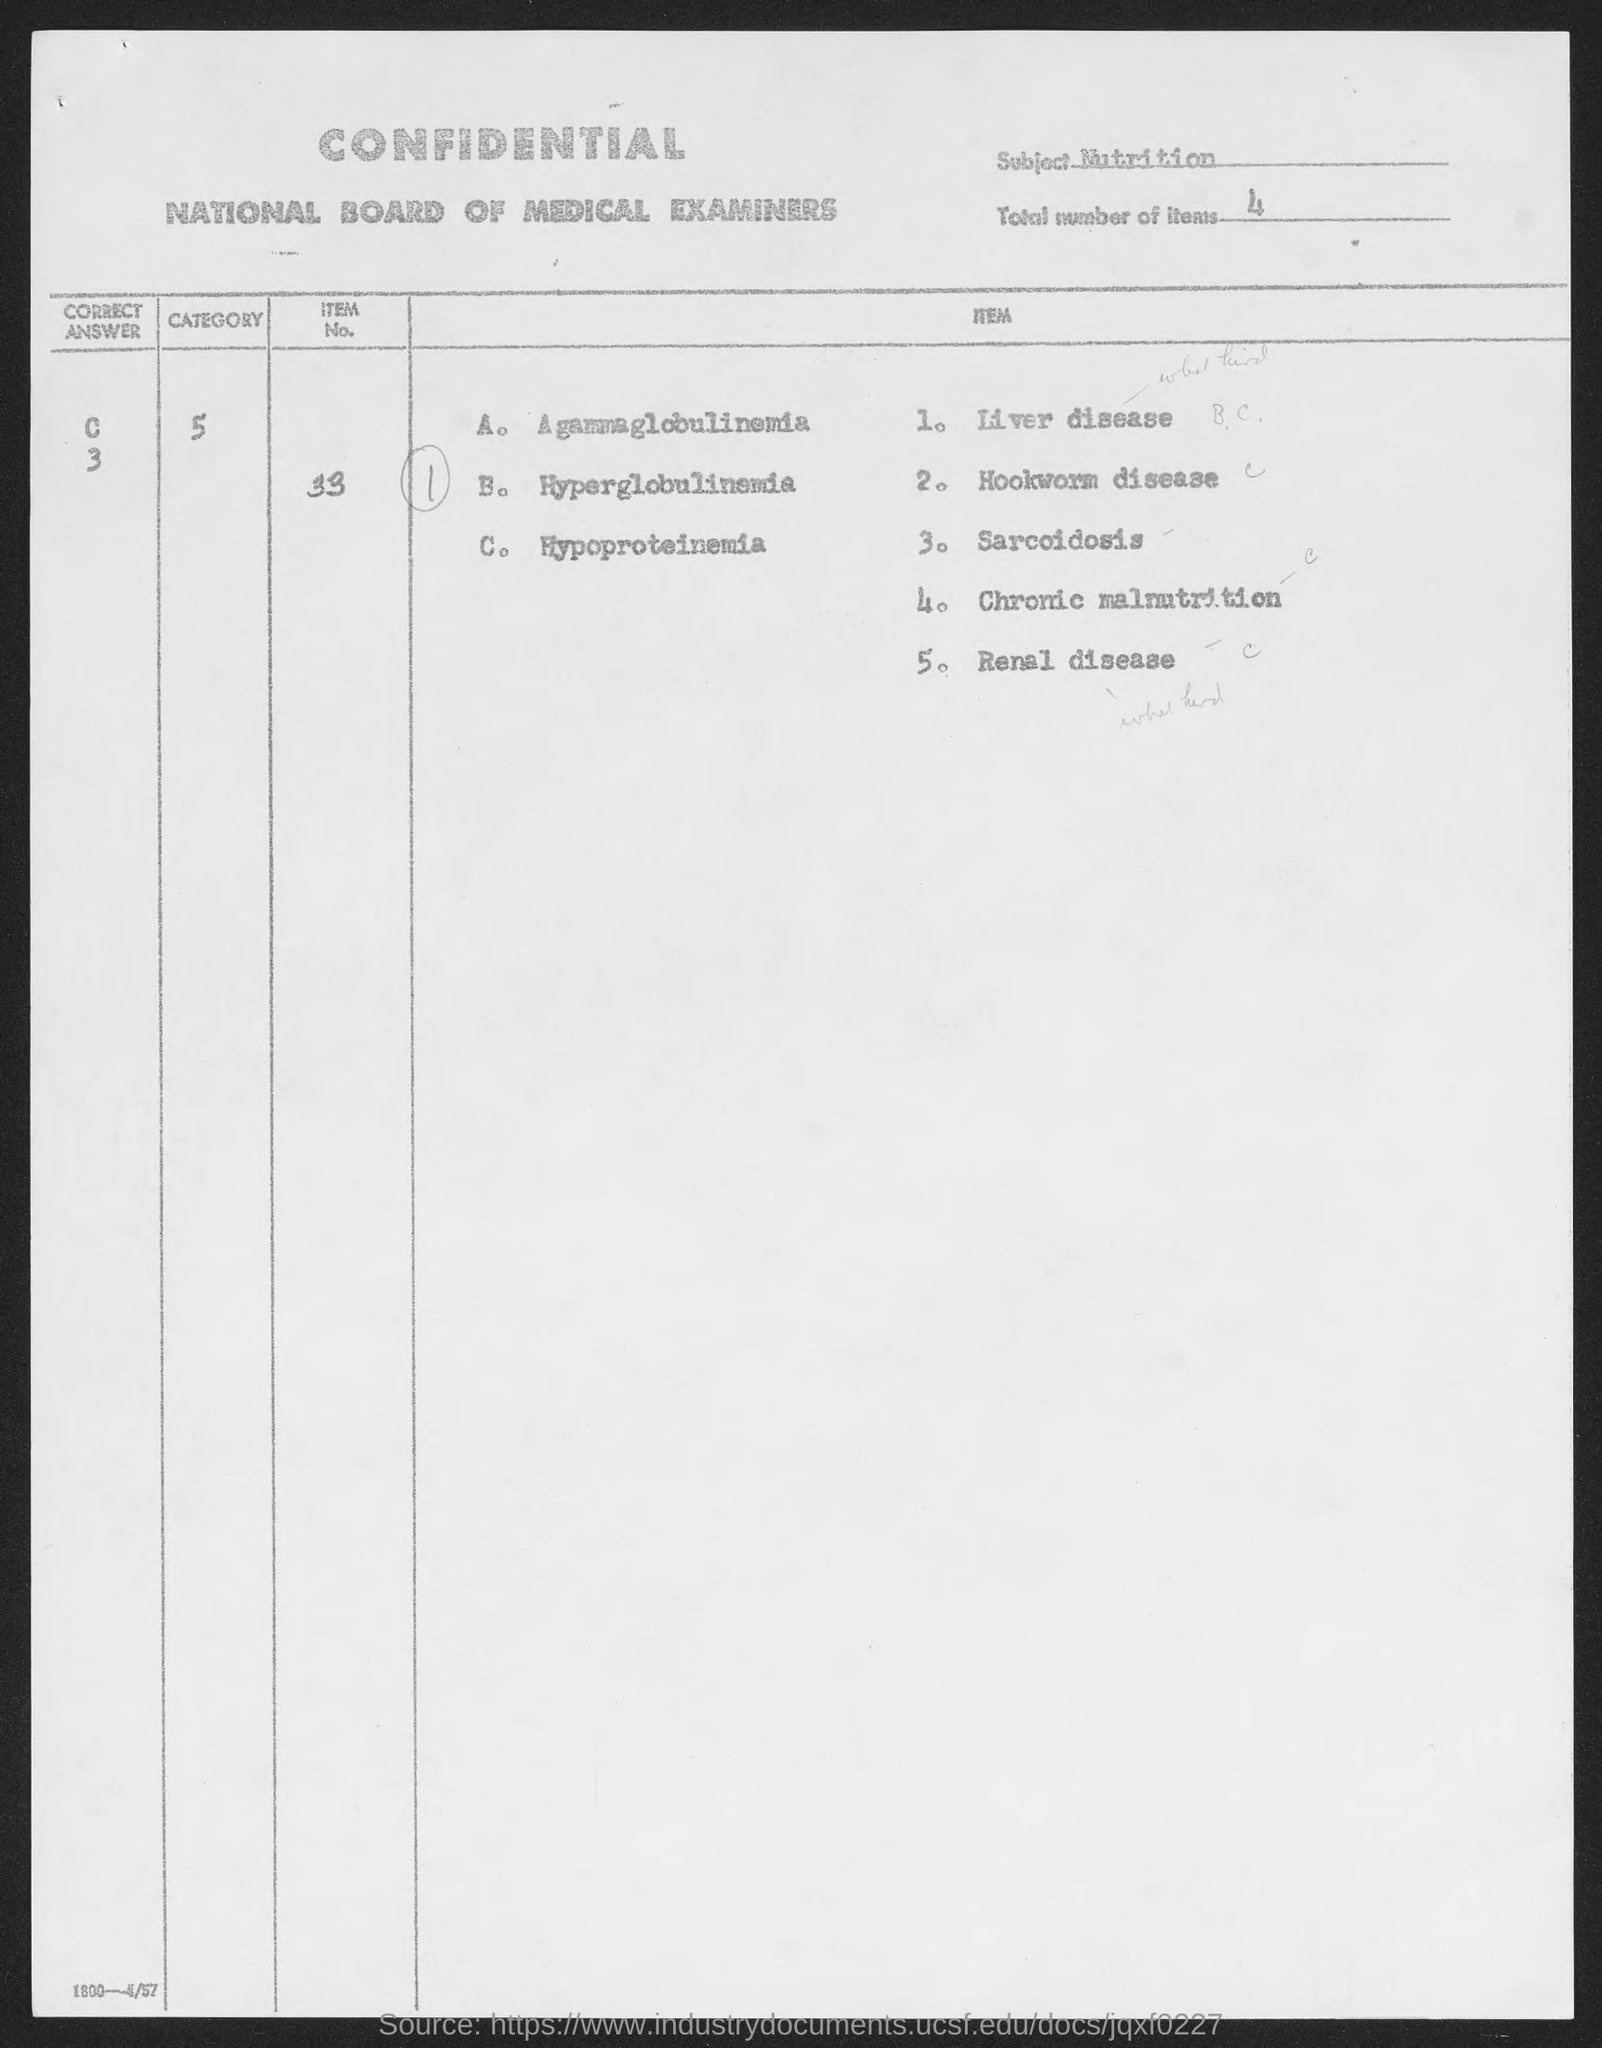Indicate a few pertinent items in this graphic. The item number provided in the document is 33... The total number of items given in the document is 4. The subject mentioned in the document is nutrition. 